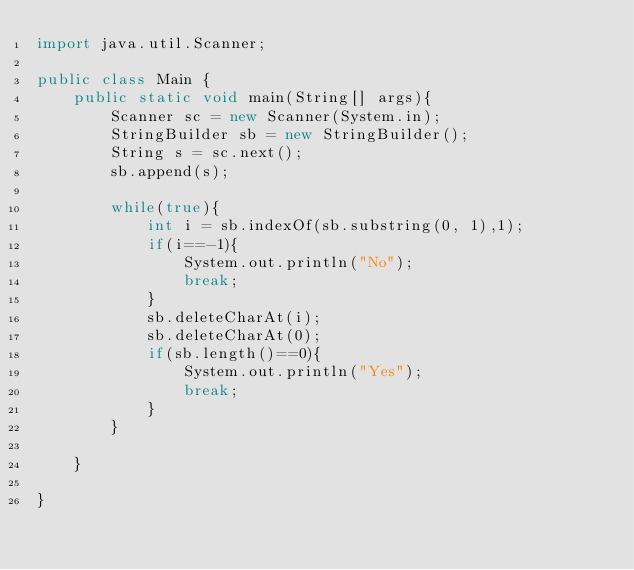Convert code to text. <code><loc_0><loc_0><loc_500><loc_500><_Java_>import java.util.Scanner;

public class Main {
	public static void main(String[] args){
		Scanner sc = new Scanner(System.in);
		StringBuilder sb = new StringBuilder();
		String s = sc.next();
		sb.append(s);
		
		while(true){
			int i = sb.indexOf(sb.substring(0, 1),1);
			if(i==-1){
				System.out.println("No");
				break;
			}
			sb.deleteCharAt(i);
			sb.deleteCharAt(0);
			if(sb.length()==0){
				System.out.println("Yes");
				break;
			}
		}
		
	}

}</code> 